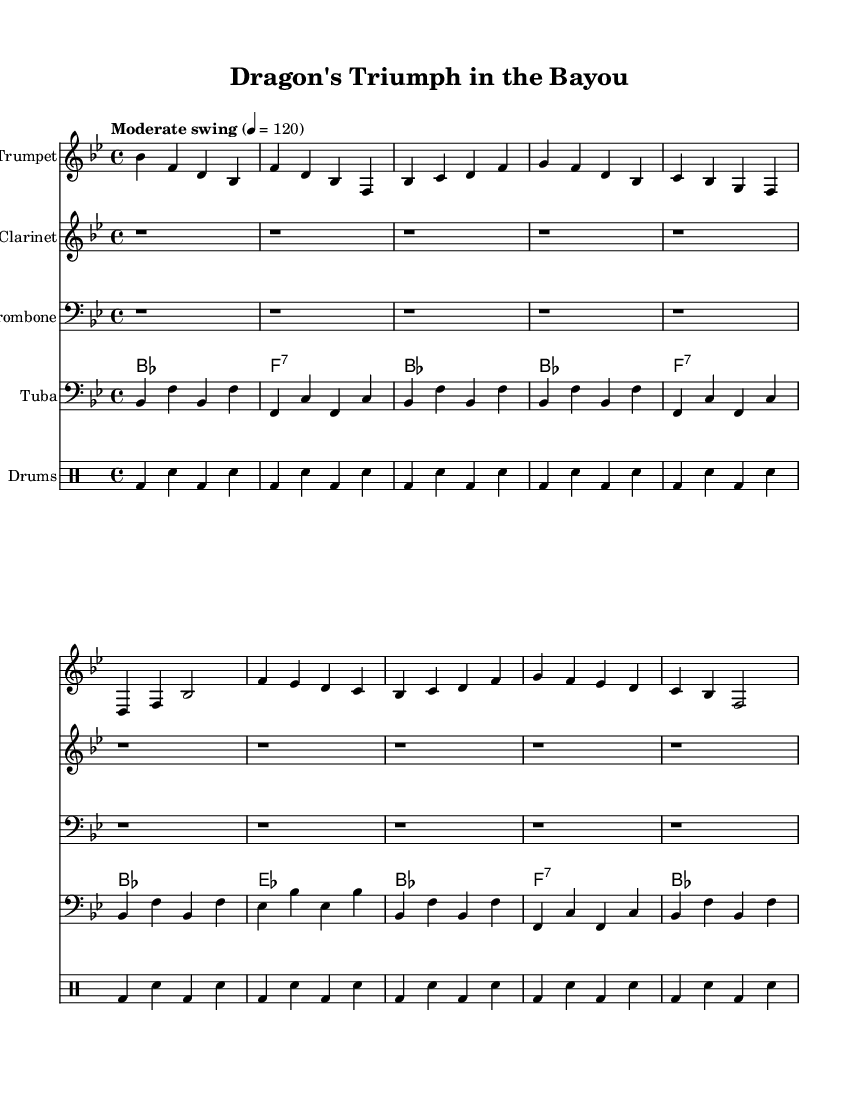What is the key signature of this music? The key signature is B flat major, which has two flats (B flat and E flat). This can be identified by examining the key signature marking at the beginning of the staff, which shows the two flat symbols.
Answer: B flat major What is the time signature of this piece? The time signature is 4/4, meaning there are four beats in each measure and the quarter note gets one beat. This is visible in the time signature marking at the beginning of the score that shows "4/4".
Answer: 4/4 What is the indicated tempo for this piece? The tempo is indicated as "Moderate swing" at a rate of 120 beats per minute. This can be seen next to the tempo marking which specifies both the style and the speed.
Answer: Moderate swing 4 = 120 How many measures are in the A section? The A section consists of 4 measures, which can be counted in the score: each distinct grouping of notes within the A section represents a measure, and there are four such groupings.
Answer: 4 What is the predominant style of this composition? The predominant style is New Orleans-style jazz, characterized by its lively and improvisational nature. This can be deduced from the use of instruments commonly associated with New Orleans jazz (like trumpet, clarinet, and trombone) and the swing feel indicated in the music.
Answer: New Orleans-style jazz How does the tuba accompaniment contribute to the overall sound? The tuba provides a steady bass line that supports the harmonic structure and rhythmic foundation of the piece. The bass notes played align with the chord changes in the banjo and contribute to a fuller ensemble sound. This can be understood by analyzing the tuba part, which emphasizes root notes and complements the harmony.
Answer: Provides a steady bass line What is the role of the drums in this arrangement? The drums play a crucial role in maintaining the groove and providing rhythmic drive to the ensemble. The drum patterns consist of bass drum and snare interactions that are common in jazz, keeping the swing feel while supporting the other instruments. This can be observed in the distinct drum part written in the drummode notation.
Answer: Maintains the groove 